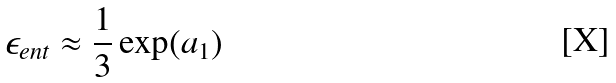<formula> <loc_0><loc_0><loc_500><loc_500>\epsilon _ { e n t } \approx \frac { 1 } { 3 } \exp ( a _ { 1 } )</formula> 